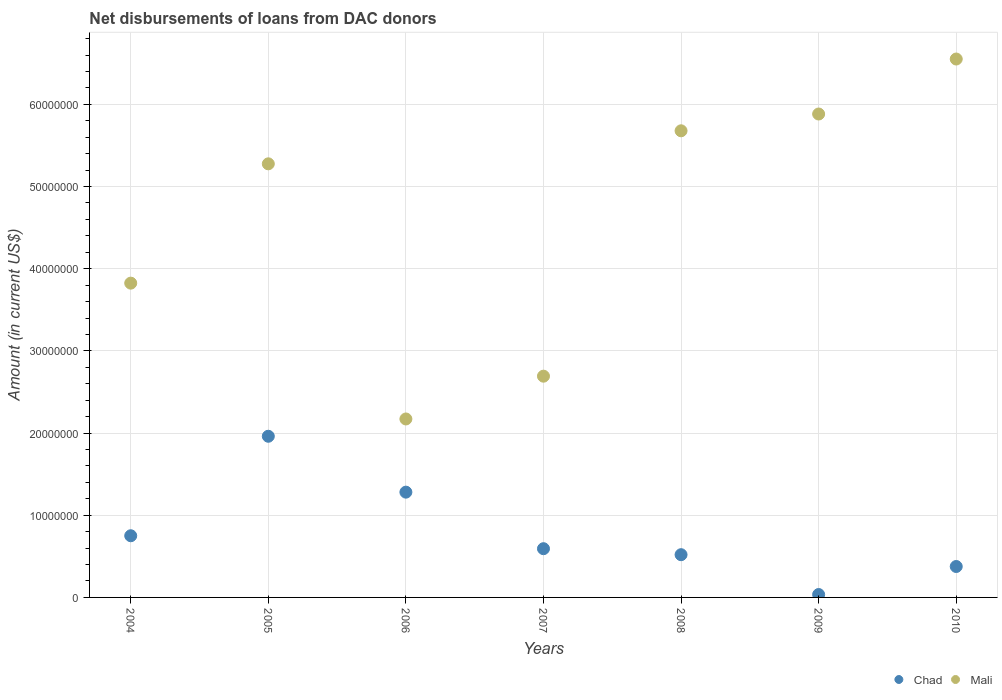What is the amount of loans disbursed in Mali in 2006?
Provide a succinct answer. 2.17e+07. Across all years, what is the maximum amount of loans disbursed in Chad?
Your answer should be compact. 1.96e+07. Across all years, what is the minimum amount of loans disbursed in Mali?
Give a very brief answer. 2.17e+07. What is the total amount of loans disbursed in Chad in the graph?
Provide a succinct answer. 5.52e+07. What is the difference between the amount of loans disbursed in Mali in 2009 and that in 2010?
Ensure brevity in your answer.  -6.69e+06. What is the difference between the amount of loans disbursed in Chad in 2006 and the amount of loans disbursed in Mali in 2005?
Your answer should be very brief. -4.00e+07. What is the average amount of loans disbursed in Mali per year?
Provide a succinct answer. 4.58e+07. In the year 2008, what is the difference between the amount of loans disbursed in Mali and amount of loans disbursed in Chad?
Ensure brevity in your answer.  5.16e+07. What is the ratio of the amount of loans disbursed in Mali in 2007 to that in 2008?
Make the answer very short. 0.47. Is the amount of loans disbursed in Chad in 2005 less than that in 2010?
Ensure brevity in your answer.  No. What is the difference between the highest and the second highest amount of loans disbursed in Chad?
Provide a short and direct response. 6.80e+06. What is the difference between the highest and the lowest amount of loans disbursed in Chad?
Ensure brevity in your answer.  1.93e+07. In how many years, is the amount of loans disbursed in Mali greater than the average amount of loans disbursed in Mali taken over all years?
Give a very brief answer. 4. How many dotlines are there?
Give a very brief answer. 2. Are the values on the major ticks of Y-axis written in scientific E-notation?
Make the answer very short. No. Does the graph contain any zero values?
Offer a terse response. No. Does the graph contain grids?
Ensure brevity in your answer.  Yes. Where does the legend appear in the graph?
Provide a short and direct response. Bottom right. What is the title of the graph?
Make the answer very short. Net disbursements of loans from DAC donors. What is the label or title of the X-axis?
Keep it short and to the point. Years. What is the Amount (in current US$) of Chad in 2004?
Your answer should be very brief. 7.50e+06. What is the Amount (in current US$) of Mali in 2004?
Your answer should be very brief. 3.82e+07. What is the Amount (in current US$) in Chad in 2005?
Give a very brief answer. 1.96e+07. What is the Amount (in current US$) of Mali in 2005?
Give a very brief answer. 5.28e+07. What is the Amount (in current US$) of Chad in 2006?
Give a very brief answer. 1.28e+07. What is the Amount (in current US$) of Mali in 2006?
Keep it short and to the point. 2.17e+07. What is the Amount (in current US$) of Chad in 2007?
Your answer should be compact. 5.93e+06. What is the Amount (in current US$) in Mali in 2007?
Offer a terse response. 2.69e+07. What is the Amount (in current US$) in Chad in 2008?
Provide a short and direct response. 5.20e+06. What is the Amount (in current US$) of Mali in 2008?
Provide a succinct answer. 5.68e+07. What is the Amount (in current US$) in Chad in 2009?
Provide a short and direct response. 3.53e+05. What is the Amount (in current US$) of Mali in 2009?
Keep it short and to the point. 5.88e+07. What is the Amount (in current US$) in Chad in 2010?
Provide a succinct answer. 3.76e+06. What is the Amount (in current US$) in Mali in 2010?
Make the answer very short. 6.55e+07. Across all years, what is the maximum Amount (in current US$) in Chad?
Provide a succinct answer. 1.96e+07. Across all years, what is the maximum Amount (in current US$) in Mali?
Ensure brevity in your answer.  6.55e+07. Across all years, what is the minimum Amount (in current US$) in Chad?
Your answer should be compact. 3.53e+05. Across all years, what is the minimum Amount (in current US$) of Mali?
Provide a short and direct response. 2.17e+07. What is the total Amount (in current US$) in Chad in the graph?
Offer a terse response. 5.52e+07. What is the total Amount (in current US$) in Mali in the graph?
Offer a very short reply. 3.21e+08. What is the difference between the Amount (in current US$) of Chad in 2004 and that in 2005?
Offer a terse response. -1.21e+07. What is the difference between the Amount (in current US$) in Mali in 2004 and that in 2005?
Offer a terse response. -1.45e+07. What is the difference between the Amount (in current US$) in Chad in 2004 and that in 2006?
Offer a terse response. -5.31e+06. What is the difference between the Amount (in current US$) in Mali in 2004 and that in 2006?
Provide a succinct answer. 1.65e+07. What is the difference between the Amount (in current US$) of Chad in 2004 and that in 2007?
Make the answer very short. 1.58e+06. What is the difference between the Amount (in current US$) of Mali in 2004 and that in 2007?
Provide a short and direct response. 1.13e+07. What is the difference between the Amount (in current US$) of Chad in 2004 and that in 2008?
Offer a very short reply. 2.30e+06. What is the difference between the Amount (in current US$) in Mali in 2004 and that in 2008?
Provide a succinct answer. -1.85e+07. What is the difference between the Amount (in current US$) of Chad in 2004 and that in 2009?
Make the answer very short. 7.15e+06. What is the difference between the Amount (in current US$) in Mali in 2004 and that in 2009?
Offer a terse response. -2.06e+07. What is the difference between the Amount (in current US$) in Chad in 2004 and that in 2010?
Keep it short and to the point. 3.74e+06. What is the difference between the Amount (in current US$) of Mali in 2004 and that in 2010?
Keep it short and to the point. -2.73e+07. What is the difference between the Amount (in current US$) of Chad in 2005 and that in 2006?
Your answer should be very brief. 6.80e+06. What is the difference between the Amount (in current US$) in Mali in 2005 and that in 2006?
Your answer should be very brief. 3.10e+07. What is the difference between the Amount (in current US$) of Chad in 2005 and that in 2007?
Offer a terse response. 1.37e+07. What is the difference between the Amount (in current US$) of Mali in 2005 and that in 2007?
Your answer should be very brief. 2.58e+07. What is the difference between the Amount (in current US$) of Chad in 2005 and that in 2008?
Give a very brief answer. 1.44e+07. What is the difference between the Amount (in current US$) of Mali in 2005 and that in 2008?
Your response must be concise. -4.02e+06. What is the difference between the Amount (in current US$) of Chad in 2005 and that in 2009?
Your answer should be compact. 1.93e+07. What is the difference between the Amount (in current US$) in Mali in 2005 and that in 2009?
Your answer should be compact. -6.06e+06. What is the difference between the Amount (in current US$) in Chad in 2005 and that in 2010?
Provide a short and direct response. 1.58e+07. What is the difference between the Amount (in current US$) in Mali in 2005 and that in 2010?
Your answer should be very brief. -1.28e+07. What is the difference between the Amount (in current US$) of Chad in 2006 and that in 2007?
Offer a very short reply. 6.88e+06. What is the difference between the Amount (in current US$) of Mali in 2006 and that in 2007?
Your answer should be compact. -5.21e+06. What is the difference between the Amount (in current US$) of Chad in 2006 and that in 2008?
Your answer should be compact. 7.61e+06. What is the difference between the Amount (in current US$) of Mali in 2006 and that in 2008?
Offer a terse response. -3.51e+07. What is the difference between the Amount (in current US$) of Chad in 2006 and that in 2009?
Provide a short and direct response. 1.25e+07. What is the difference between the Amount (in current US$) in Mali in 2006 and that in 2009?
Make the answer very short. -3.71e+07. What is the difference between the Amount (in current US$) in Chad in 2006 and that in 2010?
Ensure brevity in your answer.  9.05e+06. What is the difference between the Amount (in current US$) in Mali in 2006 and that in 2010?
Ensure brevity in your answer.  -4.38e+07. What is the difference between the Amount (in current US$) in Chad in 2007 and that in 2008?
Offer a terse response. 7.30e+05. What is the difference between the Amount (in current US$) of Mali in 2007 and that in 2008?
Offer a terse response. -2.99e+07. What is the difference between the Amount (in current US$) in Chad in 2007 and that in 2009?
Offer a very short reply. 5.58e+06. What is the difference between the Amount (in current US$) of Mali in 2007 and that in 2009?
Ensure brevity in your answer.  -3.19e+07. What is the difference between the Amount (in current US$) of Chad in 2007 and that in 2010?
Provide a succinct answer. 2.17e+06. What is the difference between the Amount (in current US$) of Mali in 2007 and that in 2010?
Offer a terse response. -3.86e+07. What is the difference between the Amount (in current US$) in Chad in 2008 and that in 2009?
Keep it short and to the point. 4.85e+06. What is the difference between the Amount (in current US$) in Mali in 2008 and that in 2009?
Keep it short and to the point. -2.04e+06. What is the difference between the Amount (in current US$) in Chad in 2008 and that in 2010?
Offer a terse response. 1.44e+06. What is the difference between the Amount (in current US$) in Mali in 2008 and that in 2010?
Your answer should be compact. -8.73e+06. What is the difference between the Amount (in current US$) in Chad in 2009 and that in 2010?
Make the answer very short. -3.41e+06. What is the difference between the Amount (in current US$) in Mali in 2009 and that in 2010?
Provide a short and direct response. -6.69e+06. What is the difference between the Amount (in current US$) of Chad in 2004 and the Amount (in current US$) of Mali in 2005?
Ensure brevity in your answer.  -4.53e+07. What is the difference between the Amount (in current US$) in Chad in 2004 and the Amount (in current US$) in Mali in 2006?
Offer a terse response. -1.42e+07. What is the difference between the Amount (in current US$) of Chad in 2004 and the Amount (in current US$) of Mali in 2007?
Your answer should be compact. -1.94e+07. What is the difference between the Amount (in current US$) of Chad in 2004 and the Amount (in current US$) of Mali in 2008?
Ensure brevity in your answer.  -4.93e+07. What is the difference between the Amount (in current US$) in Chad in 2004 and the Amount (in current US$) in Mali in 2009?
Provide a succinct answer. -5.13e+07. What is the difference between the Amount (in current US$) of Chad in 2004 and the Amount (in current US$) of Mali in 2010?
Make the answer very short. -5.80e+07. What is the difference between the Amount (in current US$) of Chad in 2005 and the Amount (in current US$) of Mali in 2006?
Keep it short and to the point. -2.10e+06. What is the difference between the Amount (in current US$) of Chad in 2005 and the Amount (in current US$) of Mali in 2007?
Provide a short and direct response. -7.31e+06. What is the difference between the Amount (in current US$) of Chad in 2005 and the Amount (in current US$) of Mali in 2008?
Offer a very short reply. -3.72e+07. What is the difference between the Amount (in current US$) of Chad in 2005 and the Amount (in current US$) of Mali in 2009?
Offer a terse response. -3.92e+07. What is the difference between the Amount (in current US$) in Chad in 2005 and the Amount (in current US$) in Mali in 2010?
Your answer should be very brief. -4.59e+07. What is the difference between the Amount (in current US$) of Chad in 2006 and the Amount (in current US$) of Mali in 2007?
Provide a succinct answer. -1.41e+07. What is the difference between the Amount (in current US$) of Chad in 2006 and the Amount (in current US$) of Mali in 2008?
Ensure brevity in your answer.  -4.40e+07. What is the difference between the Amount (in current US$) of Chad in 2006 and the Amount (in current US$) of Mali in 2009?
Give a very brief answer. -4.60e+07. What is the difference between the Amount (in current US$) of Chad in 2006 and the Amount (in current US$) of Mali in 2010?
Give a very brief answer. -5.27e+07. What is the difference between the Amount (in current US$) in Chad in 2007 and the Amount (in current US$) in Mali in 2008?
Keep it short and to the point. -5.09e+07. What is the difference between the Amount (in current US$) of Chad in 2007 and the Amount (in current US$) of Mali in 2009?
Your answer should be very brief. -5.29e+07. What is the difference between the Amount (in current US$) in Chad in 2007 and the Amount (in current US$) in Mali in 2010?
Offer a very short reply. -5.96e+07. What is the difference between the Amount (in current US$) of Chad in 2008 and the Amount (in current US$) of Mali in 2009?
Offer a terse response. -5.36e+07. What is the difference between the Amount (in current US$) in Chad in 2008 and the Amount (in current US$) in Mali in 2010?
Ensure brevity in your answer.  -6.03e+07. What is the difference between the Amount (in current US$) of Chad in 2009 and the Amount (in current US$) of Mali in 2010?
Give a very brief answer. -6.52e+07. What is the average Amount (in current US$) of Chad per year?
Ensure brevity in your answer.  7.88e+06. What is the average Amount (in current US$) of Mali per year?
Give a very brief answer. 4.58e+07. In the year 2004, what is the difference between the Amount (in current US$) of Chad and Amount (in current US$) of Mali?
Your response must be concise. -3.07e+07. In the year 2005, what is the difference between the Amount (in current US$) of Chad and Amount (in current US$) of Mali?
Make the answer very short. -3.32e+07. In the year 2006, what is the difference between the Amount (in current US$) in Chad and Amount (in current US$) in Mali?
Your answer should be compact. -8.90e+06. In the year 2007, what is the difference between the Amount (in current US$) in Chad and Amount (in current US$) in Mali?
Offer a terse response. -2.10e+07. In the year 2008, what is the difference between the Amount (in current US$) in Chad and Amount (in current US$) in Mali?
Give a very brief answer. -5.16e+07. In the year 2009, what is the difference between the Amount (in current US$) of Chad and Amount (in current US$) of Mali?
Ensure brevity in your answer.  -5.85e+07. In the year 2010, what is the difference between the Amount (in current US$) of Chad and Amount (in current US$) of Mali?
Your answer should be compact. -6.18e+07. What is the ratio of the Amount (in current US$) of Chad in 2004 to that in 2005?
Your answer should be compact. 0.38. What is the ratio of the Amount (in current US$) in Mali in 2004 to that in 2005?
Keep it short and to the point. 0.72. What is the ratio of the Amount (in current US$) of Chad in 2004 to that in 2006?
Make the answer very short. 0.59. What is the ratio of the Amount (in current US$) in Mali in 2004 to that in 2006?
Provide a succinct answer. 1.76. What is the ratio of the Amount (in current US$) in Chad in 2004 to that in 2007?
Give a very brief answer. 1.27. What is the ratio of the Amount (in current US$) of Mali in 2004 to that in 2007?
Make the answer very short. 1.42. What is the ratio of the Amount (in current US$) of Chad in 2004 to that in 2008?
Offer a terse response. 1.44. What is the ratio of the Amount (in current US$) in Mali in 2004 to that in 2008?
Keep it short and to the point. 0.67. What is the ratio of the Amount (in current US$) in Chad in 2004 to that in 2009?
Give a very brief answer. 21.26. What is the ratio of the Amount (in current US$) of Mali in 2004 to that in 2009?
Make the answer very short. 0.65. What is the ratio of the Amount (in current US$) of Chad in 2004 to that in 2010?
Offer a very short reply. 1.99. What is the ratio of the Amount (in current US$) of Mali in 2004 to that in 2010?
Provide a succinct answer. 0.58. What is the ratio of the Amount (in current US$) of Chad in 2005 to that in 2006?
Offer a very short reply. 1.53. What is the ratio of the Amount (in current US$) of Mali in 2005 to that in 2006?
Provide a short and direct response. 2.43. What is the ratio of the Amount (in current US$) in Chad in 2005 to that in 2007?
Your answer should be very brief. 3.31. What is the ratio of the Amount (in current US$) of Mali in 2005 to that in 2007?
Offer a very short reply. 1.96. What is the ratio of the Amount (in current US$) in Chad in 2005 to that in 2008?
Keep it short and to the point. 3.77. What is the ratio of the Amount (in current US$) of Mali in 2005 to that in 2008?
Give a very brief answer. 0.93. What is the ratio of the Amount (in current US$) of Chad in 2005 to that in 2009?
Give a very brief answer. 55.56. What is the ratio of the Amount (in current US$) of Mali in 2005 to that in 2009?
Your answer should be very brief. 0.9. What is the ratio of the Amount (in current US$) in Chad in 2005 to that in 2010?
Offer a very short reply. 5.21. What is the ratio of the Amount (in current US$) of Mali in 2005 to that in 2010?
Ensure brevity in your answer.  0.81. What is the ratio of the Amount (in current US$) of Chad in 2006 to that in 2007?
Give a very brief answer. 2.16. What is the ratio of the Amount (in current US$) in Mali in 2006 to that in 2007?
Offer a terse response. 0.81. What is the ratio of the Amount (in current US$) in Chad in 2006 to that in 2008?
Offer a very short reply. 2.46. What is the ratio of the Amount (in current US$) in Mali in 2006 to that in 2008?
Offer a very short reply. 0.38. What is the ratio of the Amount (in current US$) in Chad in 2006 to that in 2009?
Your answer should be compact. 36.29. What is the ratio of the Amount (in current US$) of Mali in 2006 to that in 2009?
Give a very brief answer. 0.37. What is the ratio of the Amount (in current US$) in Chad in 2006 to that in 2010?
Provide a short and direct response. 3.4. What is the ratio of the Amount (in current US$) of Mali in 2006 to that in 2010?
Keep it short and to the point. 0.33. What is the ratio of the Amount (in current US$) of Chad in 2007 to that in 2008?
Keep it short and to the point. 1.14. What is the ratio of the Amount (in current US$) of Mali in 2007 to that in 2008?
Make the answer very short. 0.47. What is the ratio of the Amount (in current US$) of Chad in 2007 to that in 2009?
Offer a very short reply. 16.8. What is the ratio of the Amount (in current US$) of Mali in 2007 to that in 2009?
Offer a very short reply. 0.46. What is the ratio of the Amount (in current US$) in Chad in 2007 to that in 2010?
Ensure brevity in your answer.  1.58. What is the ratio of the Amount (in current US$) in Mali in 2007 to that in 2010?
Provide a short and direct response. 0.41. What is the ratio of the Amount (in current US$) in Chad in 2008 to that in 2009?
Ensure brevity in your answer.  14.73. What is the ratio of the Amount (in current US$) of Mali in 2008 to that in 2009?
Keep it short and to the point. 0.97. What is the ratio of the Amount (in current US$) of Chad in 2008 to that in 2010?
Give a very brief answer. 1.38. What is the ratio of the Amount (in current US$) in Mali in 2008 to that in 2010?
Ensure brevity in your answer.  0.87. What is the ratio of the Amount (in current US$) in Chad in 2009 to that in 2010?
Keep it short and to the point. 0.09. What is the ratio of the Amount (in current US$) in Mali in 2009 to that in 2010?
Your answer should be very brief. 0.9. What is the difference between the highest and the second highest Amount (in current US$) of Chad?
Give a very brief answer. 6.80e+06. What is the difference between the highest and the second highest Amount (in current US$) of Mali?
Your answer should be very brief. 6.69e+06. What is the difference between the highest and the lowest Amount (in current US$) in Chad?
Make the answer very short. 1.93e+07. What is the difference between the highest and the lowest Amount (in current US$) of Mali?
Offer a very short reply. 4.38e+07. 